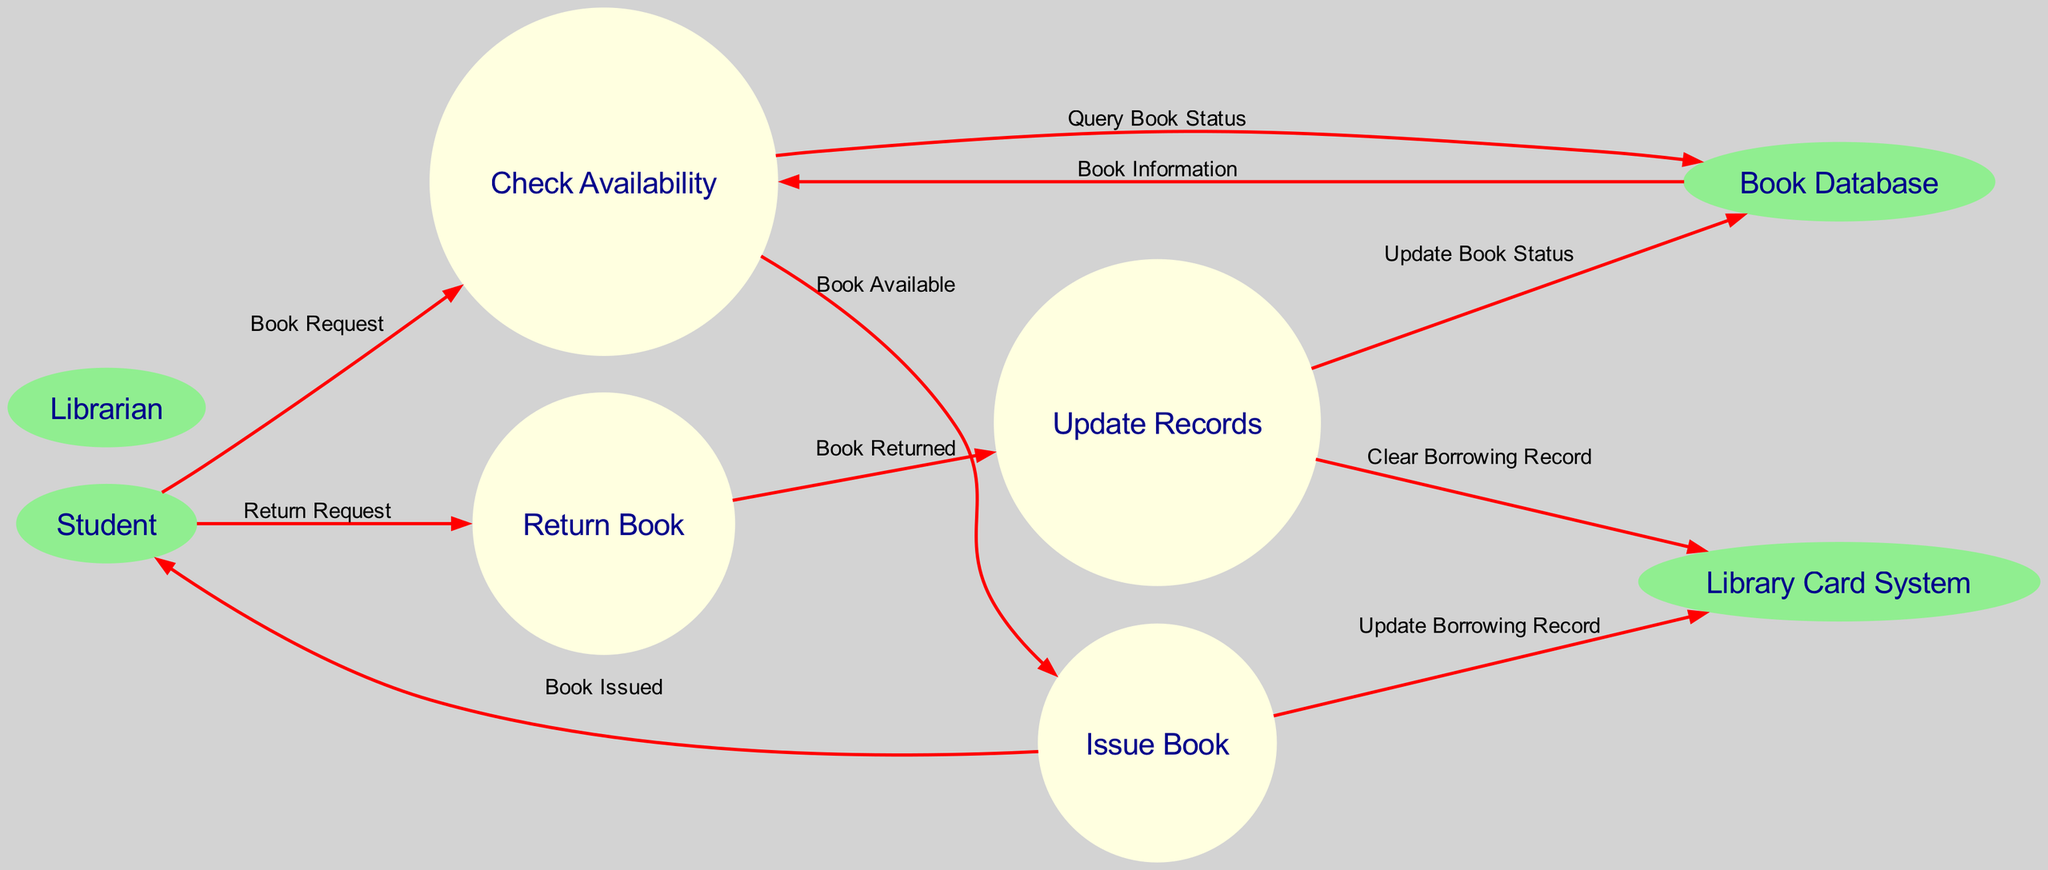What is the first process in the flow? The flow starts with the "Check Availability" process as the first action initiated by the Student when they request a book.
Answer: Check Availability How many entities are represented in the diagram? There are four entities shown in the diagram, which are Student, Librarian, Book Database, and Library Card System.
Answer: Four What is the output of the "Check Availability" process? The output of the "Check Availability" process is "Book Available," indicating whether a requested book can be borrowed.
Answer: Book Available Which process is responsible for updating the borrowing record? The "Issue Book" process is responsible for updating the borrowing record by sending information to the Library Card System.
Answer: Issue Book How does the Student return a book? The Student initiates the process by sending a "Return Request" to the "Return Book" process after they have completed their borrowing period.
Answer: Return Request What flow occurs after a book is returned? After a book is returned, the "Return Book" process sends a "Book Returned" signal to "Update Records" to update the system regarding the status of the book.
Answer: Book Returned Which database is updated after the records are cleared? The "Book Database" is updated after the "Update Records" process has cleared the borrowing record from the Library Card System.
Answer: Book Database What kind of relationship exists between the "Book Database" and the "Check Availability"? The "Book Database" provides "Book Information" in response to a "Query Book Status" initiated by the "Check Availability" process, indicating a query-response relationship.
Answer: Query-Response How many processes are in the diagram? There are four processes in the diagram: Check Availability, Issue Book, Return Book, and Update Records.
Answer: Four 